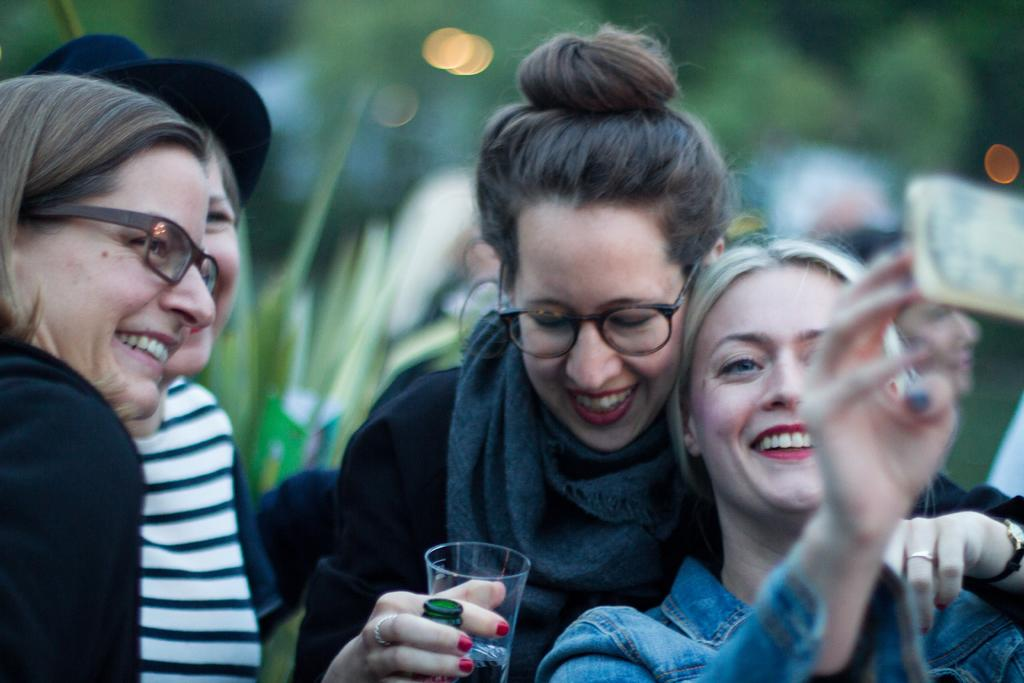How many people are in the image? There are four persons in the image. What is the facial expression of the people in the image? The persons are smiling. What is one person holding in the image? One person is holding a glass with her hand. Can you describe the background of the image? The background of the image is blurred. What type of shade is being used by the person in the image? There is no shade present in the image; it is not mentioned in the provided facts. 